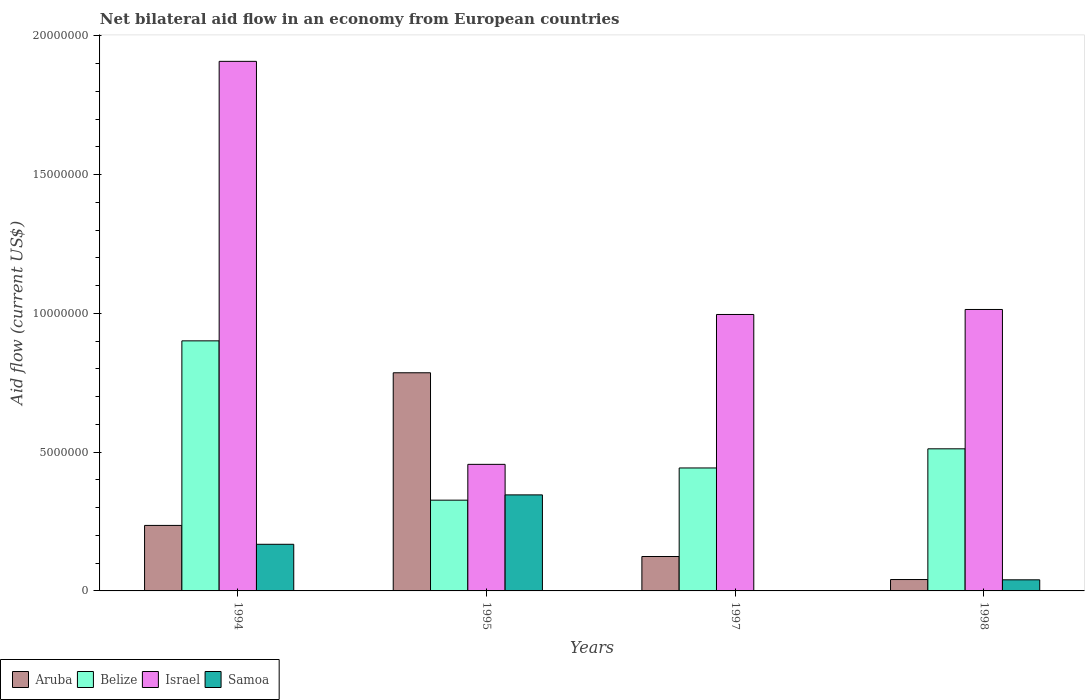How many groups of bars are there?
Make the answer very short. 4. Are the number of bars on each tick of the X-axis equal?
Your response must be concise. No. How many bars are there on the 2nd tick from the left?
Your answer should be very brief. 4. How many bars are there on the 4th tick from the right?
Your answer should be compact. 4. What is the label of the 3rd group of bars from the left?
Provide a short and direct response. 1997. What is the net bilateral aid flow in Israel in 1995?
Provide a short and direct response. 4.56e+06. Across all years, what is the maximum net bilateral aid flow in Samoa?
Offer a very short reply. 3.46e+06. In which year was the net bilateral aid flow in Aruba maximum?
Offer a very short reply. 1995. What is the total net bilateral aid flow in Israel in the graph?
Make the answer very short. 4.37e+07. What is the difference between the net bilateral aid flow in Israel in 1994 and that in 1997?
Your answer should be very brief. 9.12e+06. What is the difference between the net bilateral aid flow in Samoa in 1997 and the net bilateral aid flow in Israel in 1994?
Make the answer very short. -1.91e+07. What is the average net bilateral aid flow in Belize per year?
Keep it short and to the point. 5.46e+06. In the year 1995, what is the difference between the net bilateral aid flow in Israel and net bilateral aid flow in Samoa?
Your answer should be compact. 1.10e+06. What is the ratio of the net bilateral aid flow in Israel in 1995 to that in 1997?
Offer a terse response. 0.46. Is the net bilateral aid flow in Samoa in 1995 less than that in 1998?
Your answer should be compact. No. What is the difference between the highest and the second highest net bilateral aid flow in Belize?
Offer a terse response. 3.89e+06. What is the difference between the highest and the lowest net bilateral aid flow in Israel?
Provide a succinct answer. 1.45e+07. Is it the case that in every year, the sum of the net bilateral aid flow in Samoa and net bilateral aid flow in Aruba is greater than the net bilateral aid flow in Israel?
Your response must be concise. No. How many bars are there?
Ensure brevity in your answer.  15. Are all the bars in the graph horizontal?
Ensure brevity in your answer.  No. Does the graph contain any zero values?
Make the answer very short. Yes. Does the graph contain grids?
Your response must be concise. No. Where does the legend appear in the graph?
Your answer should be very brief. Bottom left. How many legend labels are there?
Provide a succinct answer. 4. How are the legend labels stacked?
Your answer should be compact. Horizontal. What is the title of the graph?
Offer a very short reply. Net bilateral aid flow in an economy from European countries. What is the label or title of the X-axis?
Provide a succinct answer. Years. What is the label or title of the Y-axis?
Give a very brief answer. Aid flow (current US$). What is the Aid flow (current US$) in Aruba in 1994?
Keep it short and to the point. 2.36e+06. What is the Aid flow (current US$) of Belize in 1994?
Provide a short and direct response. 9.01e+06. What is the Aid flow (current US$) of Israel in 1994?
Provide a short and direct response. 1.91e+07. What is the Aid flow (current US$) in Samoa in 1994?
Give a very brief answer. 1.68e+06. What is the Aid flow (current US$) of Aruba in 1995?
Provide a short and direct response. 7.86e+06. What is the Aid flow (current US$) of Belize in 1995?
Provide a succinct answer. 3.27e+06. What is the Aid flow (current US$) in Israel in 1995?
Provide a succinct answer. 4.56e+06. What is the Aid flow (current US$) of Samoa in 1995?
Make the answer very short. 3.46e+06. What is the Aid flow (current US$) in Aruba in 1997?
Make the answer very short. 1.24e+06. What is the Aid flow (current US$) of Belize in 1997?
Offer a terse response. 4.43e+06. What is the Aid flow (current US$) in Israel in 1997?
Offer a very short reply. 9.96e+06. What is the Aid flow (current US$) in Aruba in 1998?
Offer a very short reply. 4.10e+05. What is the Aid flow (current US$) of Belize in 1998?
Ensure brevity in your answer.  5.12e+06. What is the Aid flow (current US$) of Israel in 1998?
Offer a very short reply. 1.01e+07. Across all years, what is the maximum Aid flow (current US$) in Aruba?
Your answer should be compact. 7.86e+06. Across all years, what is the maximum Aid flow (current US$) in Belize?
Ensure brevity in your answer.  9.01e+06. Across all years, what is the maximum Aid flow (current US$) of Israel?
Make the answer very short. 1.91e+07. Across all years, what is the maximum Aid flow (current US$) of Samoa?
Ensure brevity in your answer.  3.46e+06. Across all years, what is the minimum Aid flow (current US$) of Belize?
Your answer should be very brief. 3.27e+06. Across all years, what is the minimum Aid flow (current US$) of Israel?
Give a very brief answer. 4.56e+06. What is the total Aid flow (current US$) in Aruba in the graph?
Your answer should be very brief. 1.19e+07. What is the total Aid flow (current US$) in Belize in the graph?
Give a very brief answer. 2.18e+07. What is the total Aid flow (current US$) of Israel in the graph?
Give a very brief answer. 4.37e+07. What is the total Aid flow (current US$) of Samoa in the graph?
Provide a succinct answer. 5.54e+06. What is the difference between the Aid flow (current US$) of Aruba in 1994 and that in 1995?
Keep it short and to the point. -5.50e+06. What is the difference between the Aid flow (current US$) in Belize in 1994 and that in 1995?
Provide a succinct answer. 5.74e+06. What is the difference between the Aid flow (current US$) in Israel in 1994 and that in 1995?
Provide a short and direct response. 1.45e+07. What is the difference between the Aid flow (current US$) of Samoa in 1994 and that in 1995?
Make the answer very short. -1.78e+06. What is the difference between the Aid flow (current US$) of Aruba in 1994 and that in 1997?
Make the answer very short. 1.12e+06. What is the difference between the Aid flow (current US$) in Belize in 1994 and that in 1997?
Provide a short and direct response. 4.58e+06. What is the difference between the Aid flow (current US$) of Israel in 1994 and that in 1997?
Keep it short and to the point. 9.12e+06. What is the difference between the Aid flow (current US$) of Aruba in 1994 and that in 1998?
Ensure brevity in your answer.  1.95e+06. What is the difference between the Aid flow (current US$) of Belize in 1994 and that in 1998?
Keep it short and to the point. 3.89e+06. What is the difference between the Aid flow (current US$) of Israel in 1994 and that in 1998?
Give a very brief answer. 8.94e+06. What is the difference between the Aid flow (current US$) in Samoa in 1994 and that in 1998?
Ensure brevity in your answer.  1.28e+06. What is the difference between the Aid flow (current US$) of Aruba in 1995 and that in 1997?
Keep it short and to the point. 6.62e+06. What is the difference between the Aid flow (current US$) in Belize in 1995 and that in 1997?
Provide a succinct answer. -1.16e+06. What is the difference between the Aid flow (current US$) in Israel in 1995 and that in 1997?
Give a very brief answer. -5.40e+06. What is the difference between the Aid flow (current US$) of Aruba in 1995 and that in 1998?
Provide a short and direct response. 7.45e+06. What is the difference between the Aid flow (current US$) in Belize in 1995 and that in 1998?
Give a very brief answer. -1.85e+06. What is the difference between the Aid flow (current US$) of Israel in 1995 and that in 1998?
Offer a terse response. -5.58e+06. What is the difference between the Aid flow (current US$) in Samoa in 1995 and that in 1998?
Offer a very short reply. 3.06e+06. What is the difference between the Aid flow (current US$) in Aruba in 1997 and that in 1998?
Ensure brevity in your answer.  8.30e+05. What is the difference between the Aid flow (current US$) of Belize in 1997 and that in 1998?
Keep it short and to the point. -6.90e+05. What is the difference between the Aid flow (current US$) in Aruba in 1994 and the Aid flow (current US$) in Belize in 1995?
Keep it short and to the point. -9.10e+05. What is the difference between the Aid flow (current US$) of Aruba in 1994 and the Aid flow (current US$) of Israel in 1995?
Your response must be concise. -2.20e+06. What is the difference between the Aid flow (current US$) of Aruba in 1994 and the Aid flow (current US$) of Samoa in 1995?
Keep it short and to the point. -1.10e+06. What is the difference between the Aid flow (current US$) of Belize in 1994 and the Aid flow (current US$) of Israel in 1995?
Your answer should be very brief. 4.45e+06. What is the difference between the Aid flow (current US$) in Belize in 1994 and the Aid flow (current US$) in Samoa in 1995?
Your response must be concise. 5.55e+06. What is the difference between the Aid flow (current US$) in Israel in 1994 and the Aid flow (current US$) in Samoa in 1995?
Your response must be concise. 1.56e+07. What is the difference between the Aid flow (current US$) in Aruba in 1994 and the Aid flow (current US$) in Belize in 1997?
Provide a short and direct response. -2.07e+06. What is the difference between the Aid flow (current US$) of Aruba in 1994 and the Aid flow (current US$) of Israel in 1997?
Keep it short and to the point. -7.60e+06. What is the difference between the Aid flow (current US$) of Belize in 1994 and the Aid flow (current US$) of Israel in 1997?
Give a very brief answer. -9.50e+05. What is the difference between the Aid flow (current US$) in Aruba in 1994 and the Aid flow (current US$) in Belize in 1998?
Your response must be concise. -2.76e+06. What is the difference between the Aid flow (current US$) of Aruba in 1994 and the Aid flow (current US$) of Israel in 1998?
Your response must be concise. -7.78e+06. What is the difference between the Aid flow (current US$) of Aruba in 1994 and the Aid flow (current US$) of Samoa in 1998?
Make the answer very short. 1.96e+06. What is the difference between the Aid flow (current US$) of Belize in 1994 and the Aid flow (current US$) of Israel in 1998?
Your answer should be compact. -1.13e+06. What is the difference between the Aid flow (current US$) of Belize in 1994 and the Aid flow (current US$) of Samoa in 1998?
Ensure brevity in your answer.  8.61e+06. What is the difference between the Aid flow (current US$) in Israel in 1994 and the Aid flow (current US$) in Samoa in 1998?
Provide a short and direct response. 1.87e+07. What is the difference between the Aid flow (current US$) in Aruba in 1995 and the Aid flow (current US$) in Belize in 1997?
Provide a succinct answer. 3.43e+06. What is the difference between the Aid flow (current US$) of Aruba in 1995 and the Aid flow (current US$) of Israel in 1997?
Offer a terse response. -2.10e+06. What is the difference between the Aid flow (current US$) of Belize in 1995 and the Aid flow (current US$) of Israel in 1997?
Your answer should be very brief. -6.69e+06. What is the difference between the Aid flow (current US$) in Aruba in 1995 and the Aid flow (current US$) in Belize in 1998?
Your answer should be very brief. 2.74e+06. What is the difference between the Aid flow (current US$) of Aruba in 1995 and the Aid flow (current US$) of Israel in 1998?
Your answer should be very brief. -2.28e+06. What is the difference between the Aid flow (current US$) in Aruba in 1995 and the Aid flow (current US$) in Samoa in 1998?
Ensure brevity in your answer.  7.46e+06. What is the difference between the Aid flow (current US$) of Belize in 1995 and the Aid flow (current US$) of Israel in 1998?
Your answer should be compact. -6.87e+06. What is the difference between the Aid flow (current US$) in Belize in 1995 and the Aid flow (current US$) in Samoa in 1998?
Your answer should be compact. 2.87e+06. What is the difference between the Aid flow (current US$) in Israel in 1995 and the Aid flow (current US$) in Samoa in 1998?
Provide a short and direct response. 4.16e+06. What is the difference between the Aid flow (current US$) in Aruba in 1997 and the Aid flow (current US$) in Belize in 1998?
Keep it short and to the point. -3.88e+06. What is the difference between the Aid flow (current US$) in Aruba in 1997 and the Aid flow (current US$) in Israel in 1998?
Provide a succinct answer. -8.90e+06. What is the difference between the Aid flow (current US$) in Aruba in 1997 and the Aid flow (current US$) in Samoa in 1998?
Provide a short and direct response. 8.40e+05. What is the difference between the Aid flow (current US$) in Belize in 1997 and the Aid flow (current US$) in Israel in 1998?
Give a very brief answer. -5.71e+06. What is the difference between the Aid flow (current US$) in Belize in 1997 and the Aid flow (current US$) in Samoa in 1998?
Provide a succinct answer. 4.03e+06. What is the difference between the Aid flow (current US$) of Israel in 1997 and the Aid flow (current US$) of Samoa in 1998?
Make the answer very short. 9.56e+06. What is the average Aid flow (current US$) of Aruba per year?
Give a very brief answer. 2.97e+06. What is the average Aid flow (current US$) of Belize per year?
Provide a succinct answer. 5.46e+06. What is the average Aid flow (current US$) in Israel per year?
Provide a short and direct response. 1.09e+07. What is the average Aid flow (current US$) of Samoa per year?
Provide a short and direct response. 1.38e+06. In the year 1994, what is the difference between the Aid flow (current US$) of Aruba and Aid flow (current US$) of Belize?
Provide a succinct answer. -6.65e+06. In the year 1994, what is the difference between the Aid flow (current US$) of Aruba and Aid flow (current US$) of Israel?
Provide a succinct answer. -1.67e+07. In the year 1994, what is the difference between the Aid flow (current US$) in Aruba and Aid flow (current US$) in Samoa?
Provide a succinct answer. 6.80e+05. In the year 1994, what is the difference between the Aid flow (current US$) in Belize and Aid flow (current US$) in Israel?
Keep it short and to the point. -1.01e+07. In the year 1994, what is the difference between the Aid flow (current US$) in Belize and Aid flow (current US$) in Samoa?
Offer a terse response. 7.33e+06. In the year 1994, what is the difference between the Aid flow (current US$) in Israel and Aid flow (current US$) in Samoa?
Provide a short and direct response. 1.74e+07. In the year 1995, what is the difference between the Aid flow (current US$) of Aruba and Aid flow (current US$) of Belize?
Give a very brief answer. 4.59e+06. In the year 1995, what is the difference between the Aid flow (current US$) in Aruba and Aid flow (current US$) in Israel?
Your response must be concise. 3.30e+06. In the year 1995, what is the difference between the Aid flow (current US$) in Aruba and Aid flow (current US$) in Samoa?
Keep it short and to the point. 4.40e+06. In the year 1995, what is the difference between the Aid flow (current US$) in Belize and Aid flow (current US$) in Israel?
Make the answer very short. -1.29e+06. In the year 1995, what is the difference between the Aid flow (current US$) of Israel and Aid flow (current US$) of Samoa?
Ensure brevity in your answer.  1.10e+06. In the year 1997, what is the difference between the Aid flow (current US$) of Aruba and Aid flow (current US$) of Belize?
Provide a succinct answer. -3.19e+06. In the year 1997, what is the difference between the Aid flow (current US$) of Aruba and Aid flow (current US$) of Israel?
Your response must be concise. -8.72e+06. In the year 1997, what is the difference between the Aid flow (current US$) of Belize and Aid flow (current US$) of Israel?
Keep it short and to the point. -5.53e+06. In the year 1998, what is the difference between the Aid flow (current US$) of Aruba and Aid flow (current US$) of Belize?
Your answer should be compact. -4.71e+06. In the year 1998, what is the difference between the Aid flow (current US$) of Aruba and Aid flow (current US$) of Israel?
Offer a very short reply. -9.73e+06. In the year 1998, what is the difference between the Aid flow (current US$) of Belize and Aid flow (current US$) of Israel?
Provide a succinct answer. -5.02e+06. In the year 1998, what is the difference between the Aid flow (current US$) of Belize and Aid flow (current US$) of Samoa?
Provide a short and direct response. 4.72e+06. In the year 1998, what is the difference between the Aid flow (current US$) of Israel and Aid flow (current US$) of Samoa?
Provide a succinct answer. 9.74e+06. What is the ratio of the Aid flow (current US$) in Aruba in 1994 to that in 1995?
Provide a short and direct response. 0.3. What is the ratio of the Aid flow (current US$) in Belize in 1994 to that in 1995?
Provide a short and direct response. 2.76. What is the ratio of the Aid flow (current US$) in Israel in 1994 to that in 1995?
Give a very brief answer. 4.18. What is the ratio of the Aid flow (current US$) in Samoa in 1994 to that in 1995?
Provide a short and direct response. 0.49. What is the ratio of the Aid flow (current US$) in Aruba in 1994 to that in 1997?
Offer a terse response. 1.9. What is the ratio of the Aid flow (current US$) of Belize in 1994 to that in 1997?
Offer a very short reply. 2.03. What is the ratio of the Aid flow (current US$) of Israel in 1994 to that in 1997?
Keep it short and to the point. 1.92. What is the ratio of the Aid flow (current US$) of Aruba in 1994 to that in 1998?
Offer a very short reply. 5.76. What is the ratio of the Aid flow (current US$) of Belize in 1994 to that in 1998?
Your response must be concise. 1.76. What is the ratio of the Aid flow (current US$) of Israel in 1994 to that in 1998?
Your answer should be very brief. 1.88. What is the ratio of the Aid flow (current US$) of Samoa in 1994 to that in 1998?
Ensure brevity in your answer.  4.2. What is the ratio of the Aid flow (current US$) in Aruba in 1995 to that in 1997?
Make the answer very short. 6.34. What is the ratio of the Aid flow (current US$) of Belize in 1995 to that in 1997?
Make the answer very short. 0.74. What is the ratio of the Aid flow (current US$) in Israel in 1995 to that in 1997?
Offer a very short reply. 0.46. What is the ratio of the Aid flow (current US$) of Aruba in 1995 to that in 1998?
Your response must be concise. 19.17. What is the ratio of the Aid flow (current US$) in Belize in 1995 to that in 1998?
Give a very brief answer. 0.64. What is the ratio of the Aid flow (current US$) of Israel in 1995 to that in 1998?
Your answer should be compact. 0.45. What is the ratio of the Aid flow (current US$) in Samoa in 1995 to that in 1998?
Make the answer very short. 8.65. What is the ratio of the Aid flow (current US$) in Aruba in 1997 to that in 1998?
Make the answer very short. 3.02. What is the ratio of the Aid flow (current US$) in Belize in 1997 to that in 1998?
Ensure brevity in your answer.  0.87. What is the ratio of the Aid flow (current US$) of Israel in 1997 to that in 1998?
Your response must be concise. 0.98. What is the difference between the highest and the second highest Aid flow (current US$) in Aruba?
Make the answer very short. 5.50e+06. What is the difference between the highest and the second highest Aid flow (current US$) in Belize?
Your answer should be very brief. 3.89e+06. What is the difference between the highest and the second highest Aid flow (current US$) of Israel?
Make the answer very short. 8.94e+06. What is the difference between the highest and the second highest Aid flow (current US$) in Samoa?
Your response must be concise. 1.78e+06. What is the difference between the highest and the lowest Aid flow (current US$) in Aruba?
Keep it short and to the point. 7.45e+06. What is the difference between the highest and the lowest Aid flow (current US$) in Belize?
Ensure brevity in your answer.  5.74e+06. What is the difference between the highest and the lowest Aid flow (current US$) of Israel?
Give a very brief answer. 1.45e+07. What is the difference between the highest and the lowest Aid flow (current US$) in Samoa?
Offer a very short reply. 3.46e+06. 